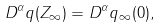<formula> <loc_0><loc_0><loc_500><loc_500>D ^ { \alpha } q ( Z _ { \infty } ) = D ^ { \alpha } q _ { \infty } ( 0 ) ,</formula> 